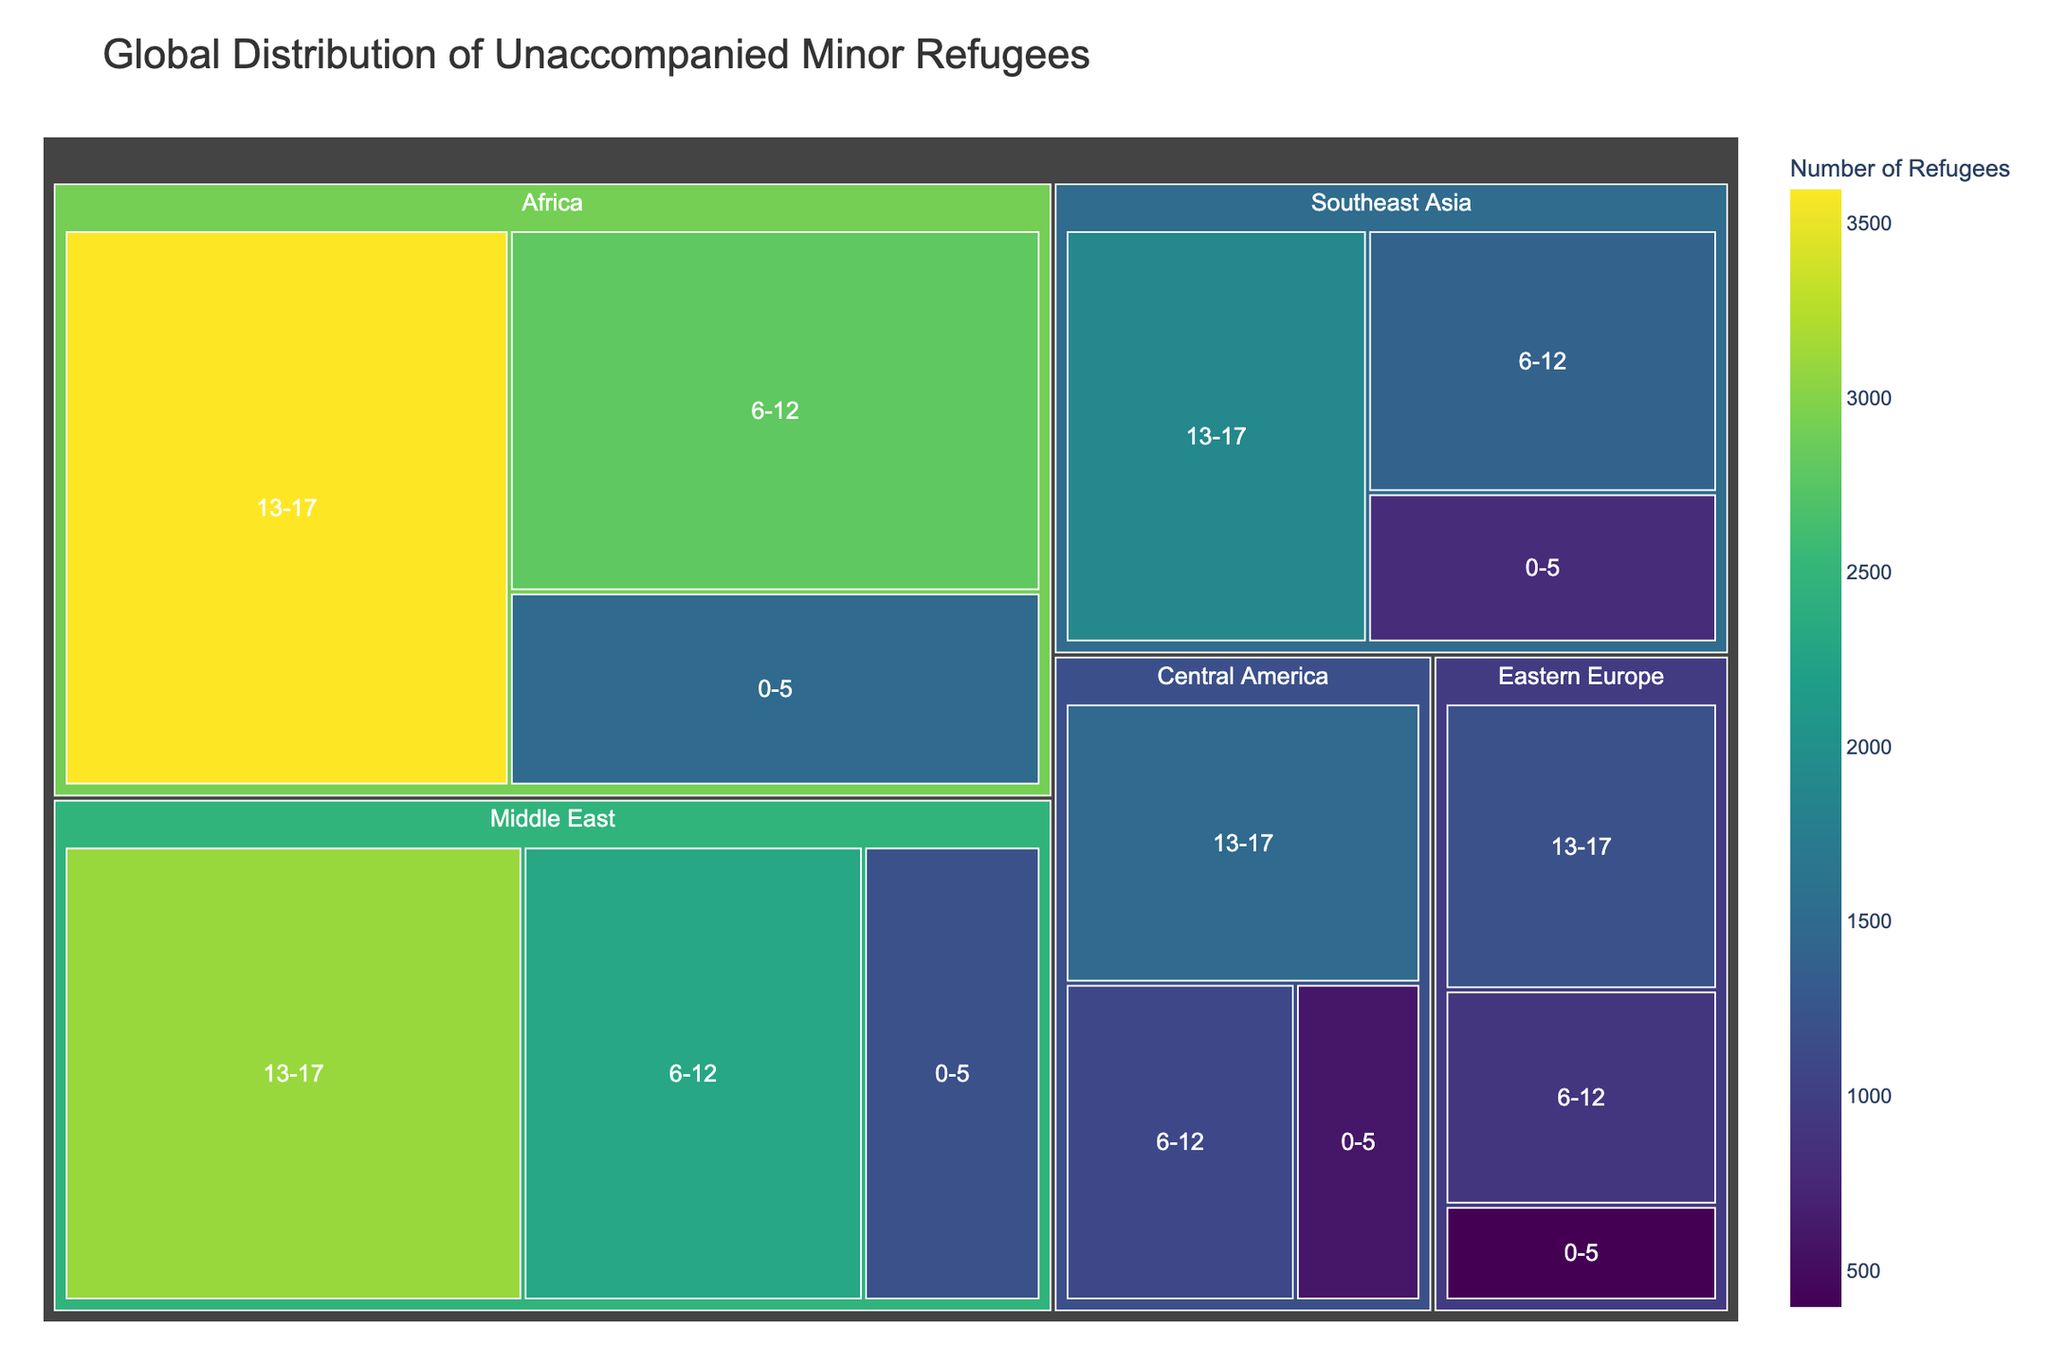What is the title of the figure? The title is usually located at the top of the figure. It helps in understanding the context and the data being represented.
Answer: Global Distribution of Unaccompanied Minor Refugees Which age group has the highest number of unaccompanied minors in the Middle East? Look for the Middle East section, then identify the color representing the highest value within its subdivisions for each age group.
Answer: 13-17 How many unaccompanied minor refugees are in the 0-5 age group across all regions? Sum the values of the 0-5 age group from all the regions: Middle East (1200) + Africa (1500) + Southeast Asia (800) + Eastern Europe (400) + Central America (600).
Answer: 4500 Which region has the lowest number of unaccompanied minors in the 13-17 age group? Compare the numbers for the 13-17 age group in each region and identify the lowest one.
Answer: Eastern Europe How does the number of unaccompanied minors in the 6-12 age group in Africa compare to those in Southeast Asia? Compare the numbers from the 6-12 age group between Africa and Southeast Asia by referring to their respective subdivisions.
Answer: Africa has more What is the combined number of unaccompanied minors in the Middle East for all age groups? Add the numbers for all three age groups in the Middle East: 0-5 (1200) + 6-12 (2300) + 13-17 (3100).
Answer: 6600 Which region represents the darkest color, and what does it signify? The color scale indicates quantity, with dark colors representing higher numbers. Identify the region with the darkest shade.
Answer: Africa, high number Is the number of unaccompanied minors in the 0-5 age group in Southeast Asia more or less than in Central America? Compare the values associated with the 0-5 age group for both Southeast Asia and Central America.
Answer: Less Which region has the most consistent distribution of numbers across all age groups? Look at each region's subdivisions to determine which has the least variation in refugee numbers across age groups.
Answer: Central America What is the difference in the number of unaccompanied minors between the 13-17 and 6-12 age groups in Africa? Subtract the number in the 6-12 age group in Africa from the number in the 13-17 age group in Africa: 3600 - 2800.
Answer: 800 